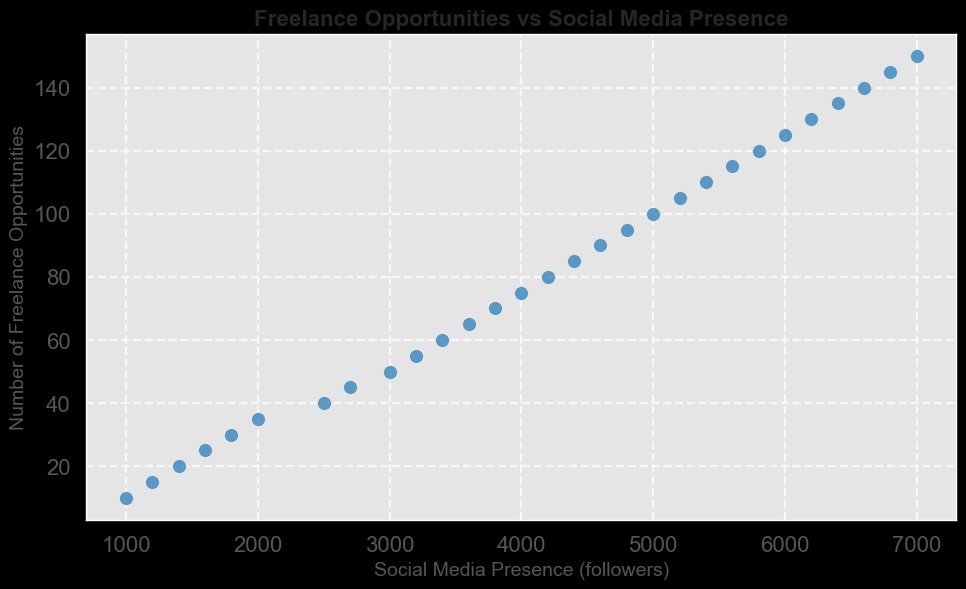Can we see a trend or pattern in the relationship between social media presence and freelance opportunities? By visual inspection, it looks like there is a positive correlation between social media presence and the number of freelance opportunities. As social media presence increases, the number of freelance opportunities also increases.
Answer: Yes, there is a positive trend Which data point has the highest number of freelance opportunities? The highest number of freelance opportunities corresponds to the highest point on the y-axis. This is the point at (7000, 150), which means 150 freelance opportunities.
Answer: 150 freelance opportunities By how much does the number of freelance opportunities increase when social media presence goes from 3000 to 5000? Identify the y-values corresponding to 3000 and 5000 on the x-axis. For 3000, the y-value is 50; for 5000, it is 100. The difference is 100 - 50 = 50 freelance opportunities.
Answer: 50 freelance opportunities Is there any data point where both social media presence and freelance opportunities are equal? Compare x-values and y-values to see if they match. There are no points where social media presence (x-value) equals freelance opportunities (y-value).
Answer: No On average, how many freelance opportunities are there for every 1000 followers on social media? The FreelanceOpportunities range from 10 to 150 as SocialMediaPresence ranges from 1000 to 7000. Calculate the average increase in freelance opportunities per 1000 followers by using the linear increase (150 - 10) / (7000/1000 - 1) = 140 / 6 ~ 23.33
Answer: Approximately 23.33 freelance opportunities Compare the freelance opportunities when social media presence is 1000 versus when it is 5000. Which one is higher and by how much? At 1000 followers, freelance opportunities are 10. At 5000 followers, freelance opportunities are 100. The difference is 100 - 10 = 90.
Answer: 5000 followers have 90 more freelance opportunities What is the social media presence for the midpoint number of freelance opportunities? The midpoint for the given set is about 80 freelance opportunities. Locate the corresponding x-value from the graph. It is approximately 4200 followers corresponding to 80 freelance opportunities.
Answer: Approximately 4200 followers How many data points are there where social media presence is above 2500 followers? Count data points with x-values greater than 2500. From the dataset, this count equals 22.
Answer: 22 data points If we want to reach 50 freelance opportunities, what range of social media presence should we aim for? Locate the y-value of 50 and find the corresponding range of x-values. Social media presence is approximately 3000 followers when y-value is 50.
Answer: Approximately 3000 followers Is the increase in freelance opportunities consistent as social media presence grows? By observing the graph, the relationship appears linear, indicating a consistent increase in freelance opportunities as social media presence grows.
Answer: Yes 